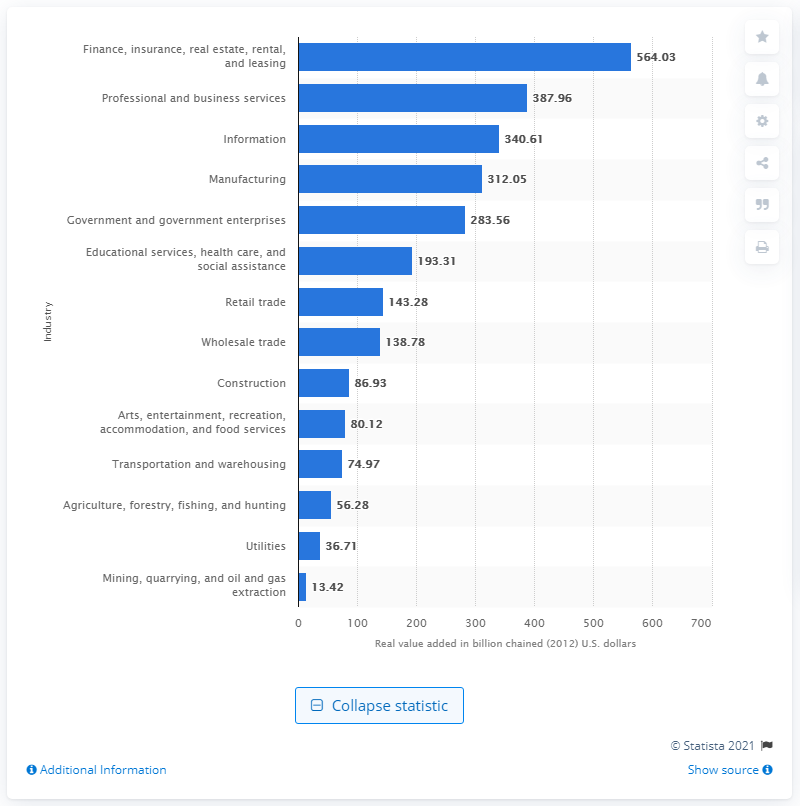Mention a couple of crucial points in this snapshot. In 2012, the finance, insurance, real estate, rental, and leasing industry contributed a total of $564.03 billion to California's Gross Domestic Product. In 2020, the information industry contributed $340.61 billion to California's Gross Domestic Product (GDP). 